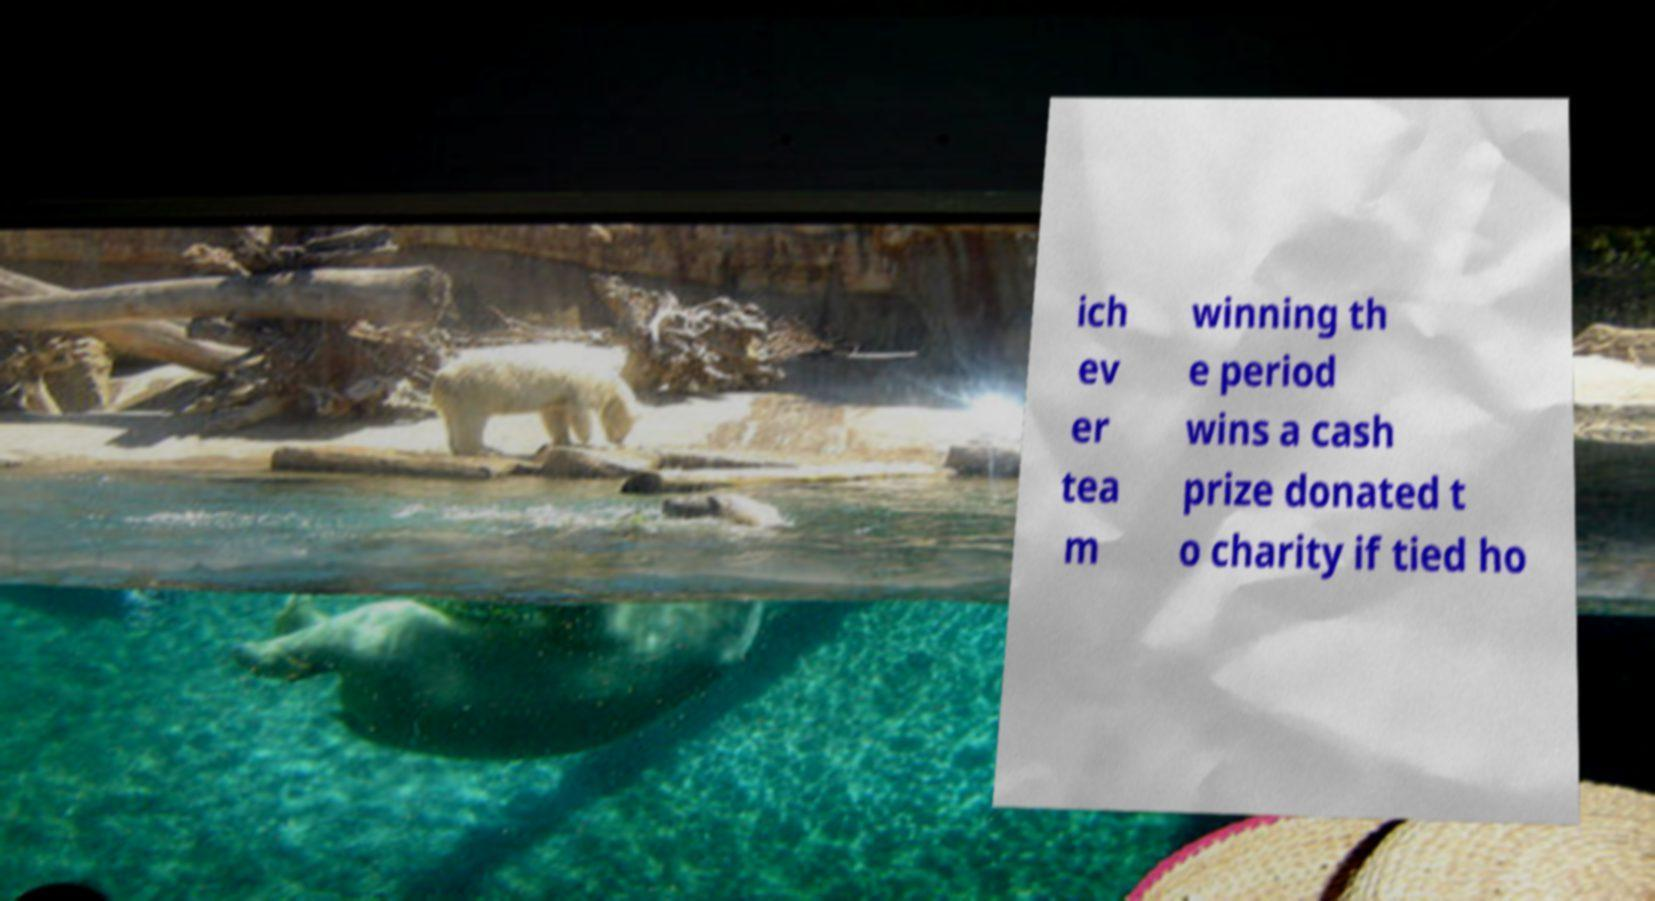What messages or text are displayed in this image? I need them in a readable, typed format. ich ev er tea m winning th e period wins a cash prize donated t o charity if tied ho 